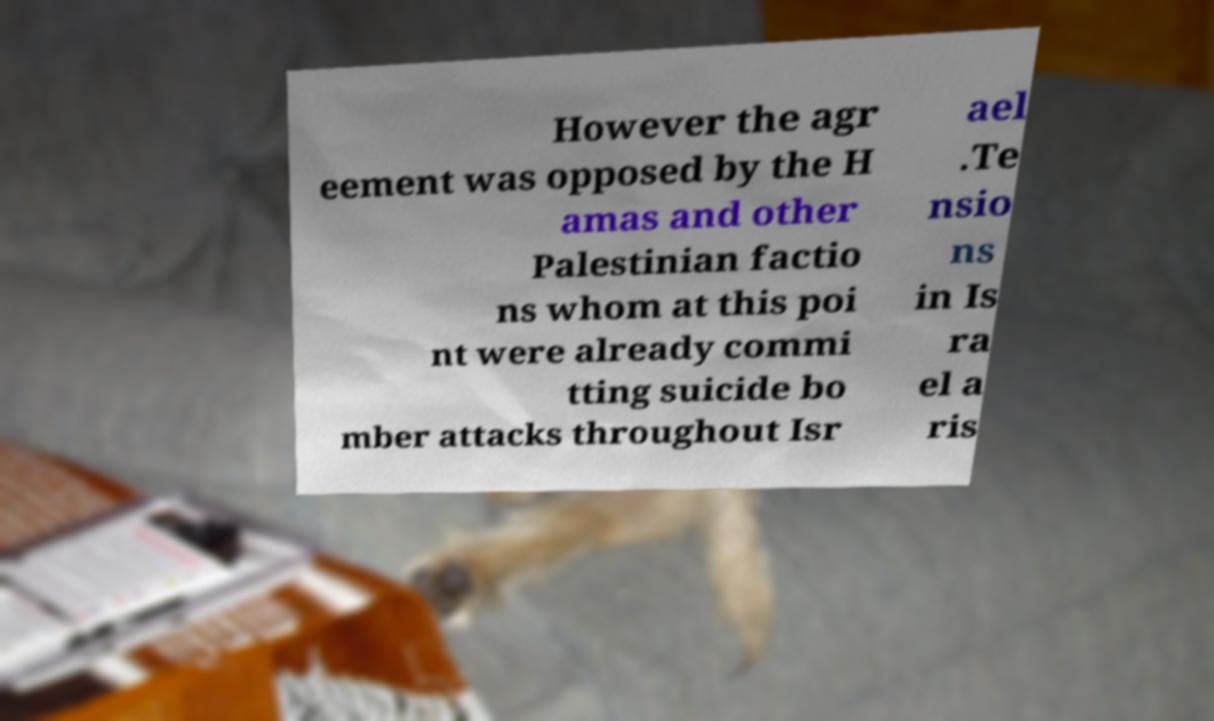I need the written content from this picture converted into text. Can you do that? However the agr eement was opposed by the H amas and other Palestinian factio ns whom at this poi nt were already commi tting suicide bo mber attacks throughout Isr ael .Te nsio ns in Is ra el a ris 